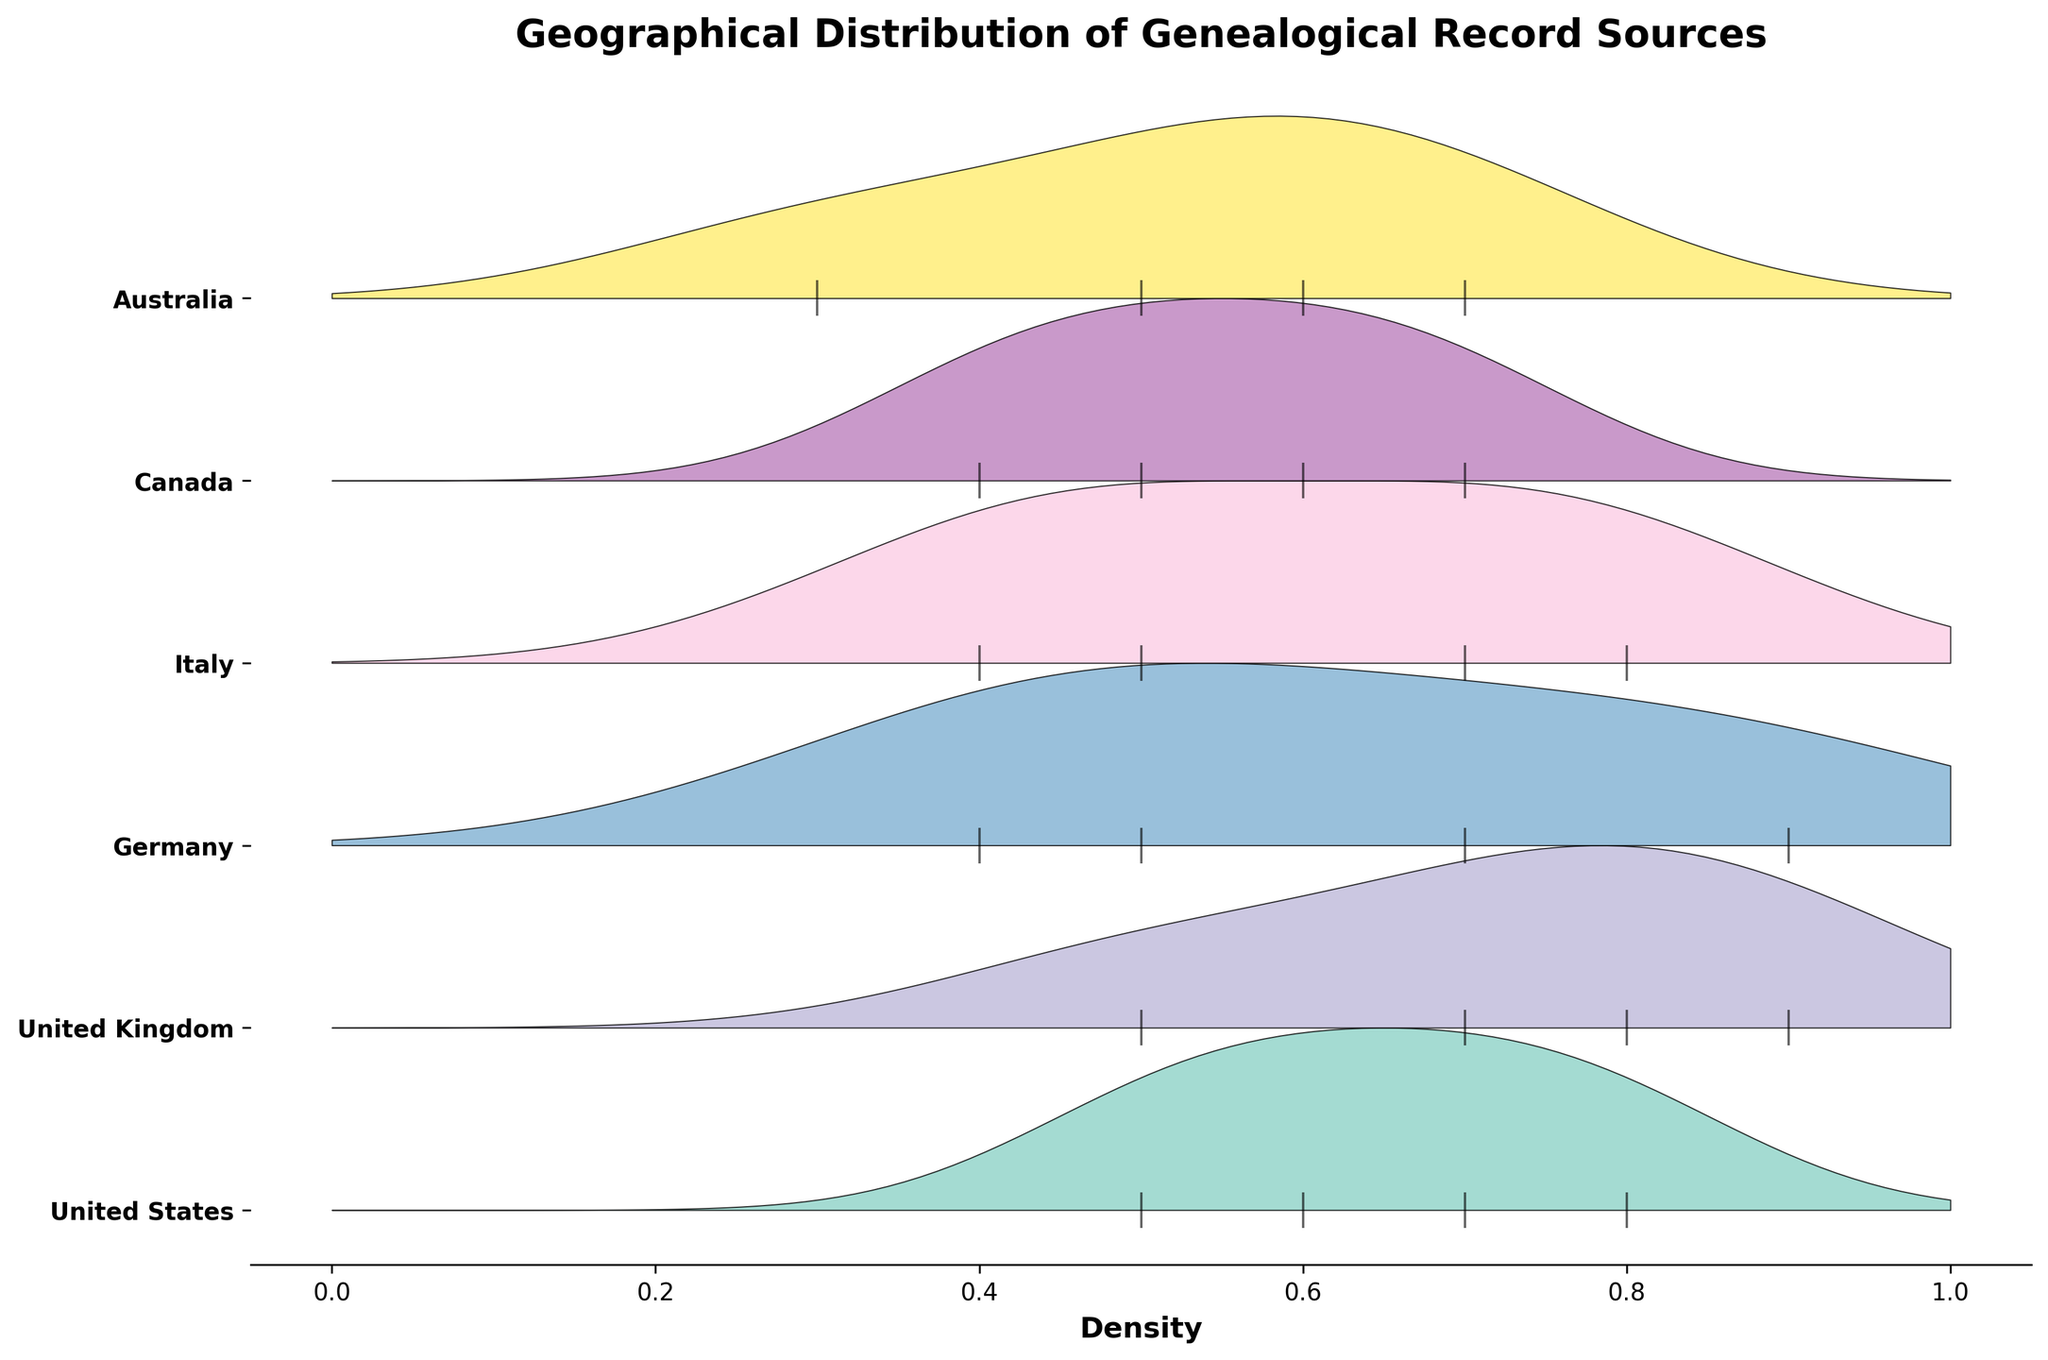What is the title of the plot? The title of the plot is displayed at the top of the figure.
Answer: Geographical Distribution of Genealogical Record Sources What is shown on the x-axis? The x-axis is labeled and shows the density of the genealogical records.
Answer: Density How many regions are represented in the plot? By counting the distinct regions listed as y-ticks, we can determine the number of regions.
Answer: 6 Which region has the highest density for census records? By looking at the region's ridgeline that has the highest peak for the census records, we can identify the region.
Answer: United States Which record type in the United Kingdom has the highest density? By examining the ridgeline for the United Kingdom and identifying the record type with the highest peak, we can determine the answer.
Answer: Parish Registers In which country is the density of Church Books highest, and what is its value? Identifying the country with the highest peak for Church Books in the ridgeline plot gives the country and the density.
Answer: Germany, 0.9 Compare the density of Birth Certificates between Australia and Canada. Which country has a higher density? By comparing the heights of the ridgelines for Birth Certificates in Australia and Canada, we can see which is higher.
Answer: Australia Which regions have a record type with a density of exactly 0.5? By looking at the tick marks along the x-axis for each region, we identify which regions have a record type with a density of 0.5.
Answer: United States, United Kingdom, Germany, Italy, Canada, Australia What is the combined density for Birth Certificates and Marriage Records in Canada? Adding the densities for Birth Certificates and Marriage Records for Canada from the ridgeline plot.
Answer: 1.1 What is the trend of densities for Census Records across all regions? Observing the peaks of ridgelines for Census Records across all regions to find a pattern.
Answer: Generally, the density decreases from the United States to Italy 